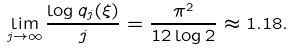Convert formula to latex. <formula><loc_0><loc_0><loc_500><loc_500>\lim _ { j \to \infty } \frac { \log q _ { j } ( \xi ) } j = \frac { \pi ^ { 2 } } { 1 2 \log 2 } \approx 1 . 1 8 .</formula> 